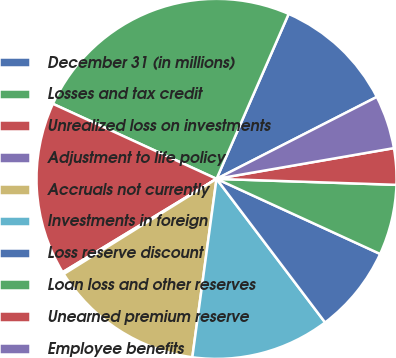Convert chart to OTSL. <chart><loc_0><loc_0><loc_500><loc_500><pie_chart><fcel>December 31 (in millions)<fcel>Losses and tax credit<fcel>Unrealized loss on investments<fcel>Adjustment to life policy<fcel>Accruals not currently<fcel>Investments in foreign<fcel>Loss reserve discount<fcel>Loan loss and other reserves<fcel>Unearned premium reserve<fcel>Employee benefits<nl><fcel>10.92%<fcel>24.72%<fcel>15.52%<fcel>0.19%<fcel>13.99%<fcel>12.45%<fcel>7.85%<fcel>6.32%<fcel>3.26%<fcel>4.79%<nl></chart> 